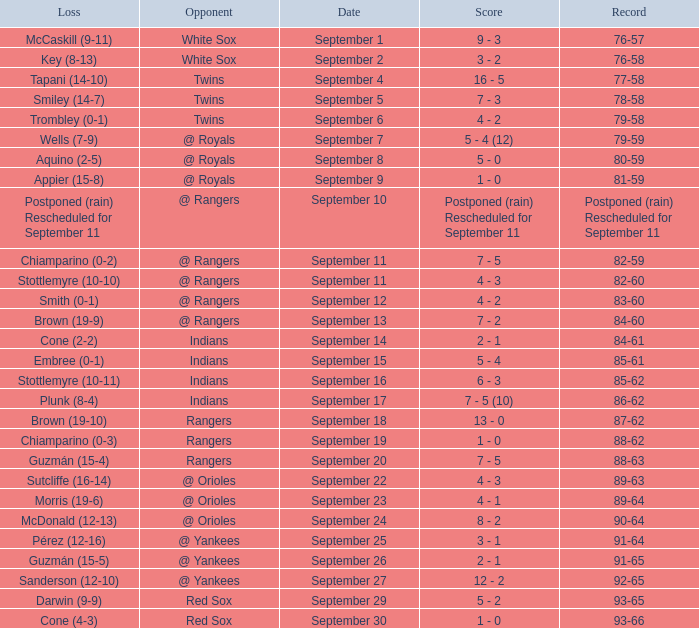What opponent has a loss of McCaskill (9-11)? White Sox. 